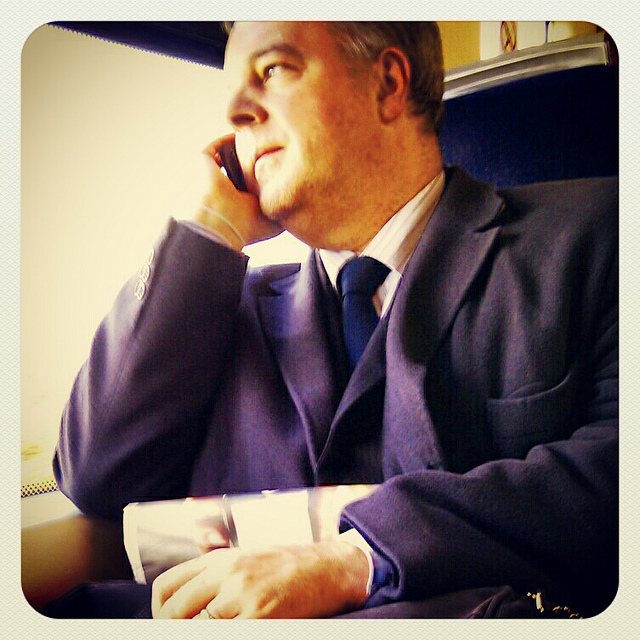What can we surmise about the person's activity in the image? The person appears to be in conversation over a mobile phone. His focused gaze outside the window and the phone at his ear suggest he is engaged in a discussion, possibly related to work or personal matters, given his formal attire. 